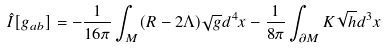<formula> <loc_0><loc_0><loc_500><loc_500>\hat { I } [ g _ { a b } ] = - \frac { 1 } { 1 6 \pi } \int _ { M } ( R - 2 \Lambda ) \sqrt { g } d ^ { 4 } x - \frac { 1 } { 8 \pi } \int _ { \partial { M } } K \sqrt { h } d ^ { 3 } x</formula> 